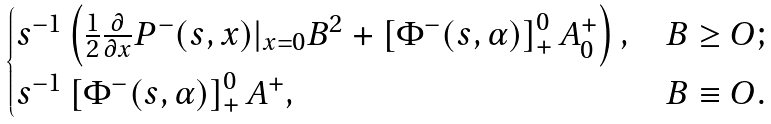<formula> <loc_0><loc_0><loc_500><loc_500>\begin{cases} s ^ { - 1 } \left ( \frac { 1 } { 2 } \frac { \partial } { \partial x } P ^ { - } ( s , x ) | _ { x = 0 } B ^ { 2 } + \left [ \Phi ^ { - } ( s , \alpha ) \right ] _ { + } ^ { 0 } A _ { 0 } ^ { + } \right ) , & B \geq O ; \\ s ^ { - 1 } \left [ \Phi ^ { - } ( s , \alpha ) \right ] _ { + } ^ { 0 } A ^ { + } , & B \equiv O . \end{cases}</formula> 